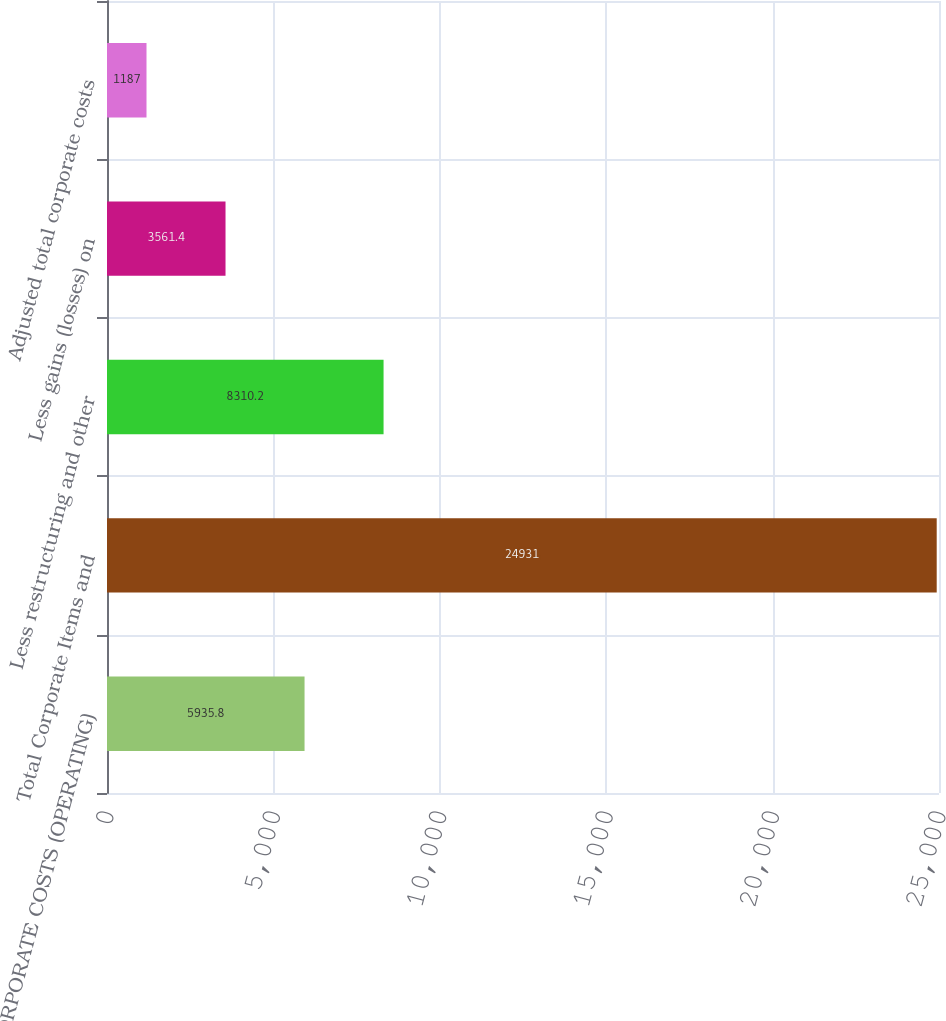Convert chart to OTSL. <chart><loc_0><loc_0><loc_500><loc_500><bar_chart><fcel>CORPORATE COSTS (OPERATING)<fcel>Total Corporate Items and<fcel>Less restructuring and other<fcel>Less gains (losses) on<fcel>Adjusted total corporate costs<nl><fcel>5935.8<fcel>24931<fcel>8310.2<fcel>3561.4<fcel>1187<nl></chart> 